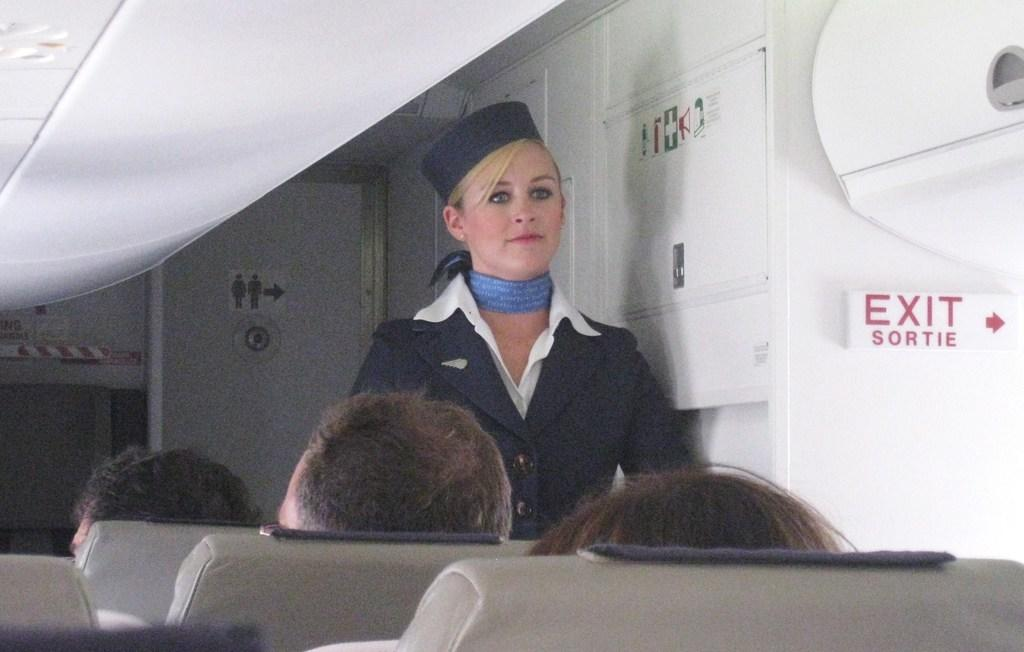Who is the main subject in the image? The main subject in the image is an air hostess. What is the air hostess doing in the image? The air hostess is standing and looking at someone. Can you describe the passengers in the image? There are people sitting in the aeroplane. What type of cow can be seen grazing in the image? There is no cow present in the image; it features an air hostess and passengers in an aeroplane. How many sheep are visible in the image? There are no sheep present in the image. 